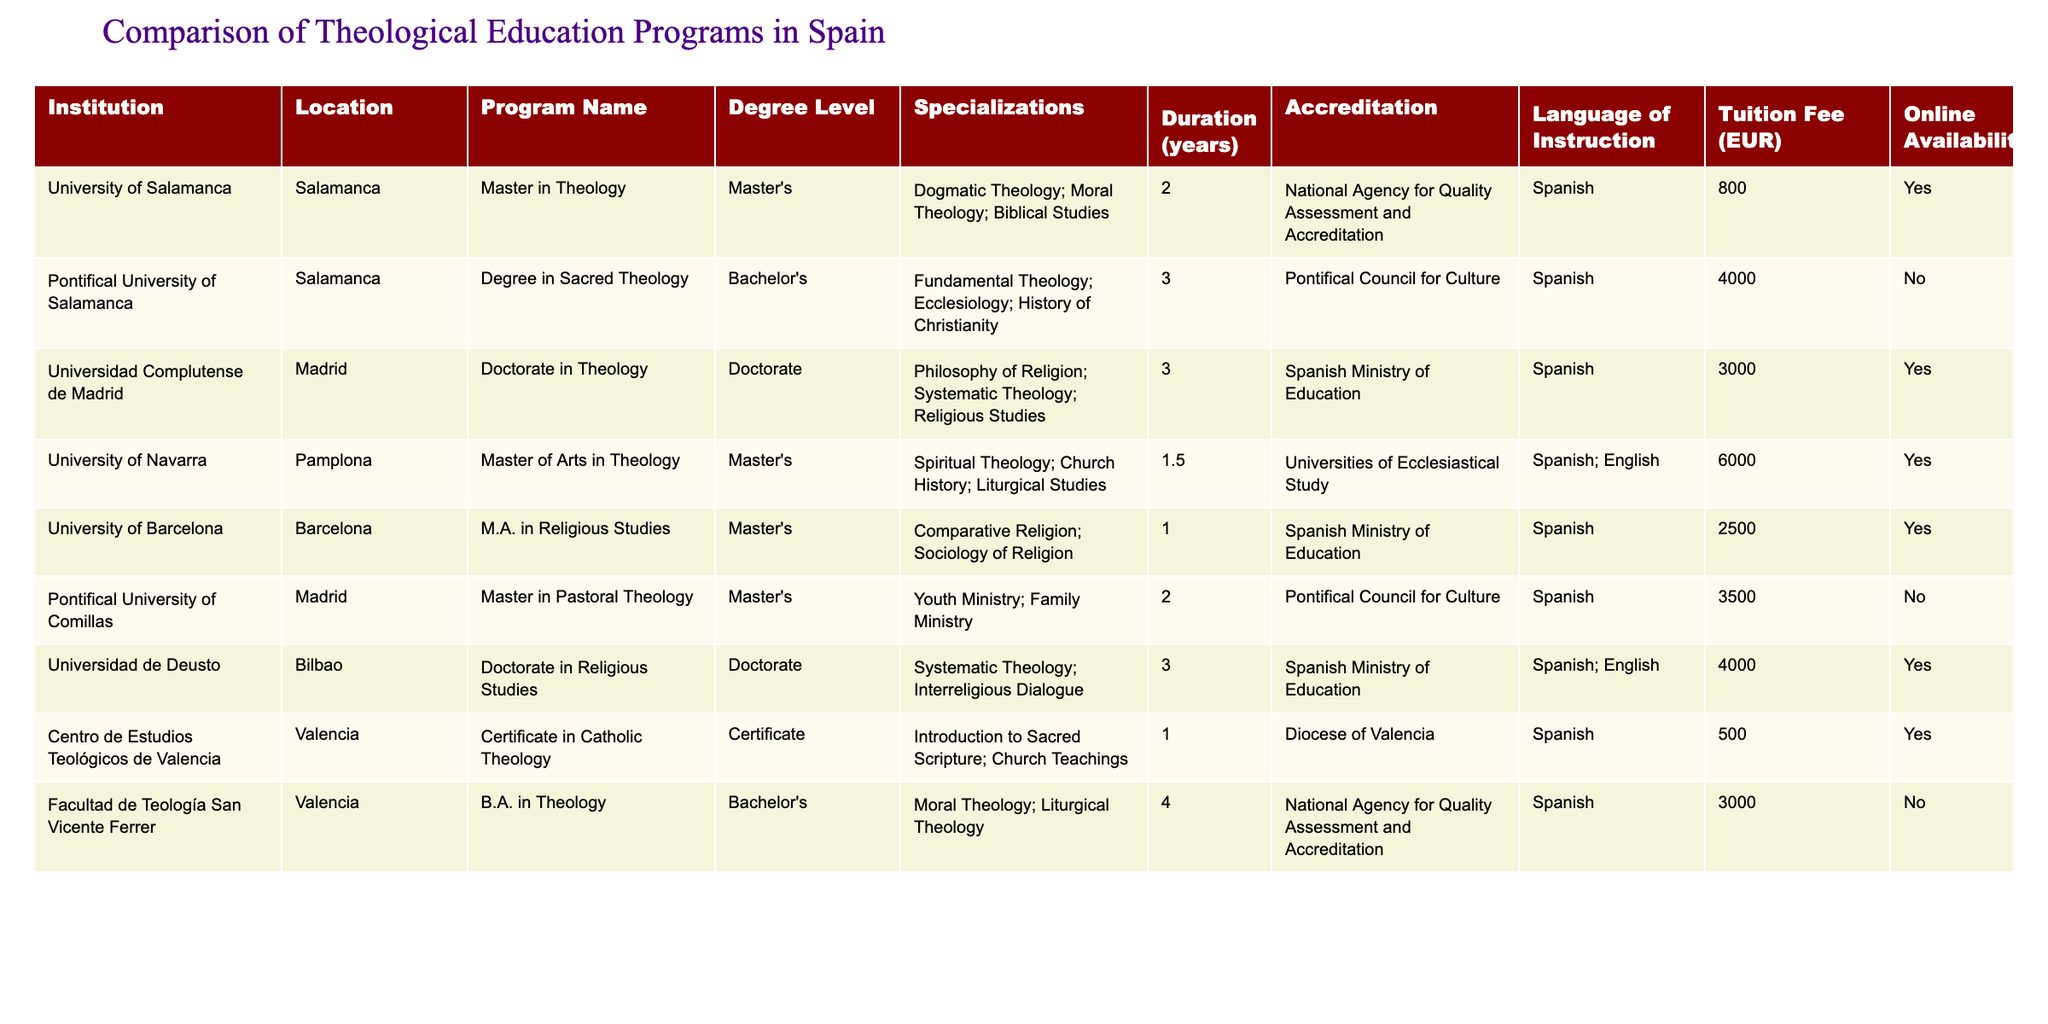What degree level is offered by the University of Salamanca? The table specifies that the University of Salamanca offers a Master in Theology, which is categorized under the Master's degree level.
Answer: Master's Which institution offers the shortest program duration? By examining the durations listed, the University of Navarra offers a Master of Arts in Theology with a duration of 1.5 years, which is the shortest compared to others.
Answer: 1.5 years What is the tuition fee for the Doctorate in Theology at the Universidad Complutense de Madrid? The fee for the Doctorate in Theology at the Universidad Complutense de Madrid is listed as 3000 EUR.
Answer: 3000 EUR Do any seminaries offer programs in English? The table indicates that the University of Navarra and Universidad de Deusto offer programs with language options including English.
Answer: Yes What is the difference in tuition fees between the Master in Theology at the University of Salamanca and the Master in Pastoral Theology at the Pontifical University of Comillas? The tuition fee at the University of Salamanca is 800 EUR, while the fee at the Pontifical University of Comillas is 3500 EUR. The difference is 3500 - 800 = 2700 EUR.
Answer: 2700 EUR Which program has the highest tuition fee, and what is that fee? The program with the highest tuition fee is the Master of Arts in Theology at the University of Navarra, with a fee of 6000 EUR.
Answer: 6000 EUR Are all programs at the Pontifical University of Salamanca taught in Spanish? The data indicates that the program at the Pontifical University of Salamanca is specifically in Spanish, confirming that it is not offered in other languages.
Answer: Yes How many programs have an online availability option? Counting the programs with online availability, there are 5 listed: Master in Theology, Doctorate in Theology, M.A. in Religious Studies, Certificate in Catholic Theology, and Doctorate in Religious Studies.
Answer: 5 What is the average duration of the programs offered? The durations of the programs are 2, 3, 3, 1.5, 1, 2, 1, 4 years. Summing these yields 2 + 3 + 3 + 1.5 + 1 + 2 + 1 + 4 = 18 years. Dividing by 8 programs gives an average of 18/8 = 2.25 years.
Answer: 2.25 years Which program offers a specialization in Family Ministry, and what is the degree level? The program that offers a specialization in Family Ministry is the Master in Pastoral Theology at the Pontifical University of Comillas, categorized at the Master's degree level.
Answer: Master's 